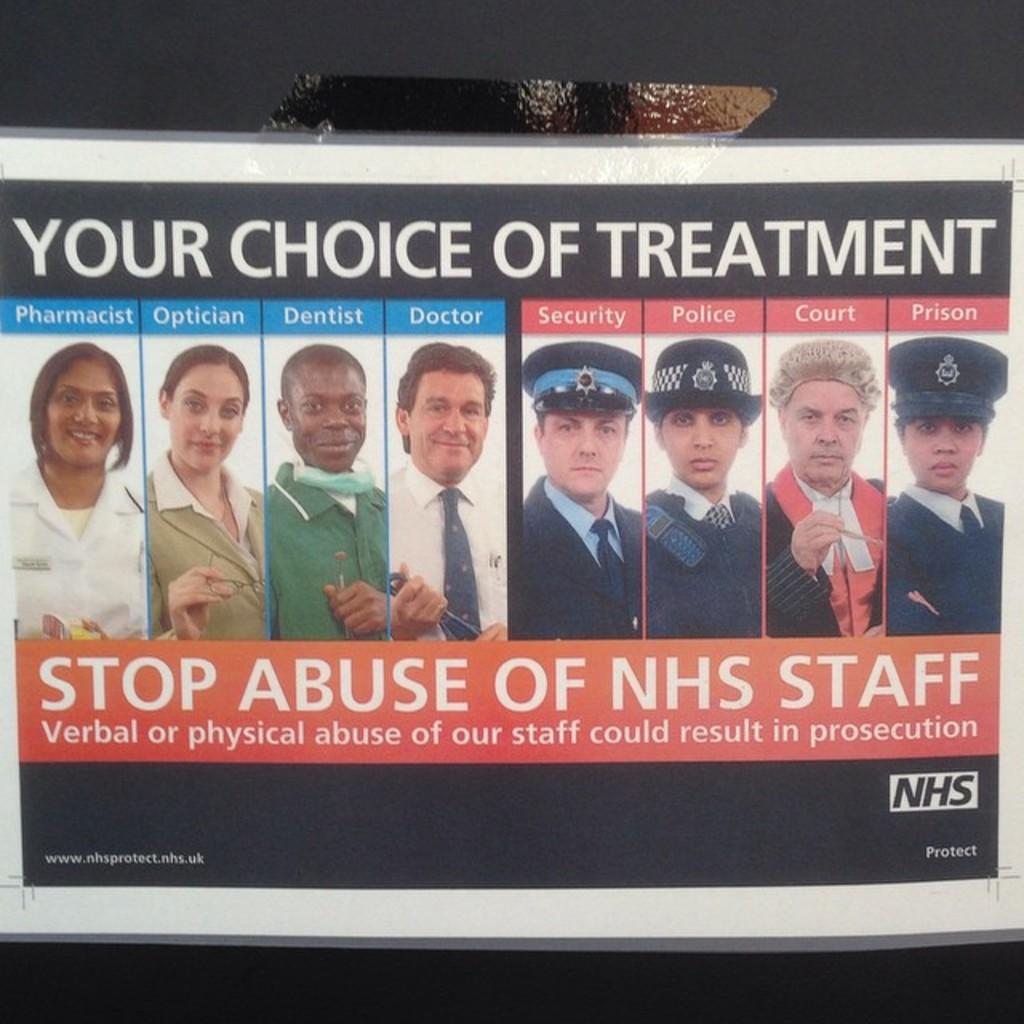What is the main object in the image? There is a poster in the image. What can be seen on the poster? The poster contains images of many persons. Is there any text on the poster? Yes, there is text at the bottom of the poster. What type of flame can be seen burning on the poster? There is no flame present on the poster; it contains images of persons and text. How does the passenger interact with the poster in the image? There is no passenger present in the image; it only shows a poster with images of persons and text. 